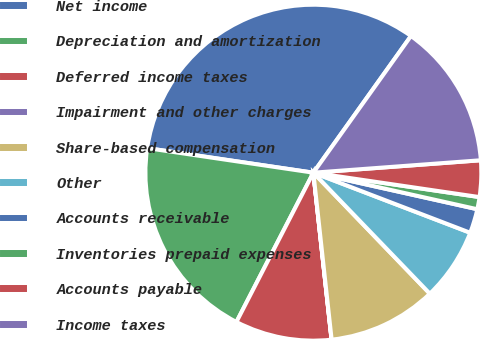Convert chart to OTSL. <chart><loc_0><loc_0><loc_500><loc_500><pie_chart><fcel>Net income<fcel>Depreciation and amortization<fcel>Deferred income taxes<fcel>Impairment and other charges<fcel>Share-based compensation<fcel>Other<fcel>Accounts receivable<fcel>Inventories prepaid expenses<fcel>Accounts payable<fcel>Income taxes<nl><fcel>32.53%<fcel>19.76%<fcel>9.3%<fcel>0.01%<fcel>10.46%<fcel>6.98%<fcel>2.33%<fcel>1.17%<fcel>3.5%<fcel>13.95%<nl></chart> 